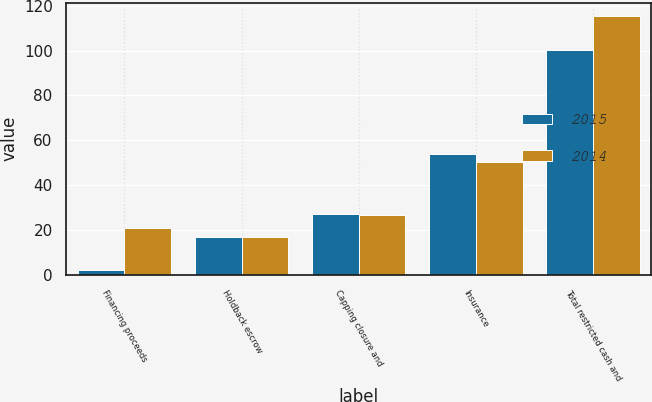Convert chart to OTSL. <chart><loc_0><loc_0><loc_500><loc_500><stacked_bar_chart><ecel><fcel>Financing proceeds<fcel>Holdback escrow<fcel>Capping closure and<fcel>Insurance<fcel>Total restricted cash and<nl><fcel>2015<fcel>2.1<fcel>16.8<fcel>27.3<fcel>54.1<fcel>100.3<nl><fcel>2014<fcel>20.9<fcel>16.8<fcel>26.7<fcel>50.4<fcel>115.6<nl></chart> 